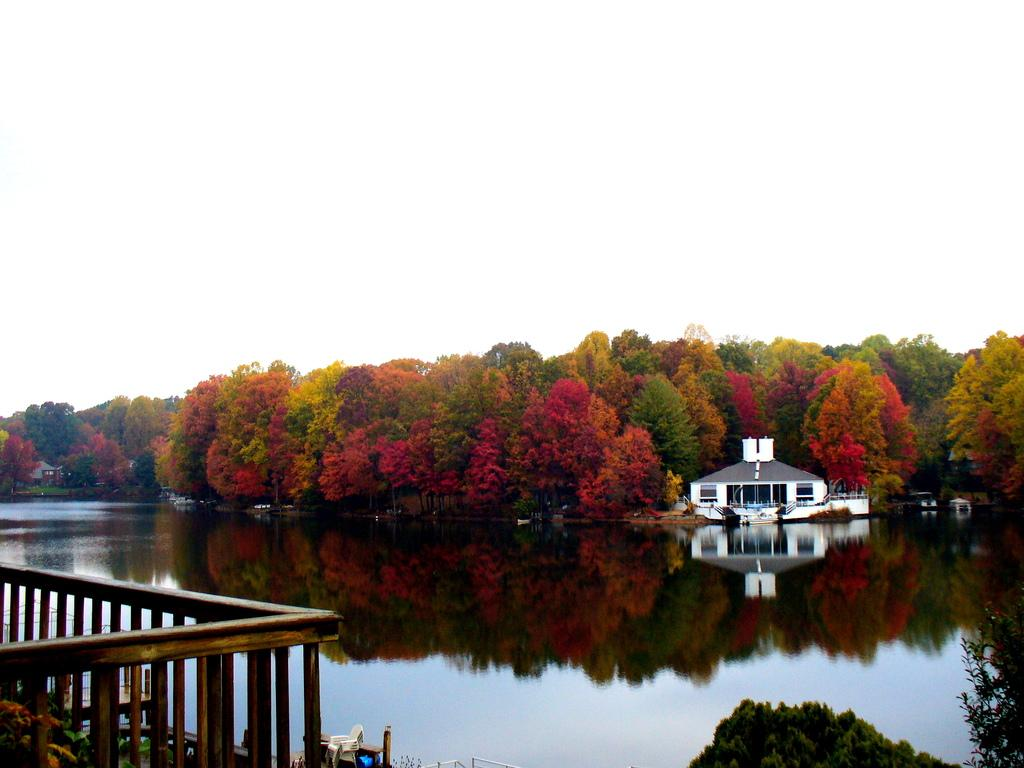What type of fence can be seen in the image? There is a wooden fence in the image. What is visible in the image besides the fence? There is water, a house, trees, and the sky visible in the image. Can you describe the background of the image? The background of the image includes trees and the sky. What type of pain is the fence experiencing in the image? The fence is not experiencing any pain in the image, as it is an inanimate object. 